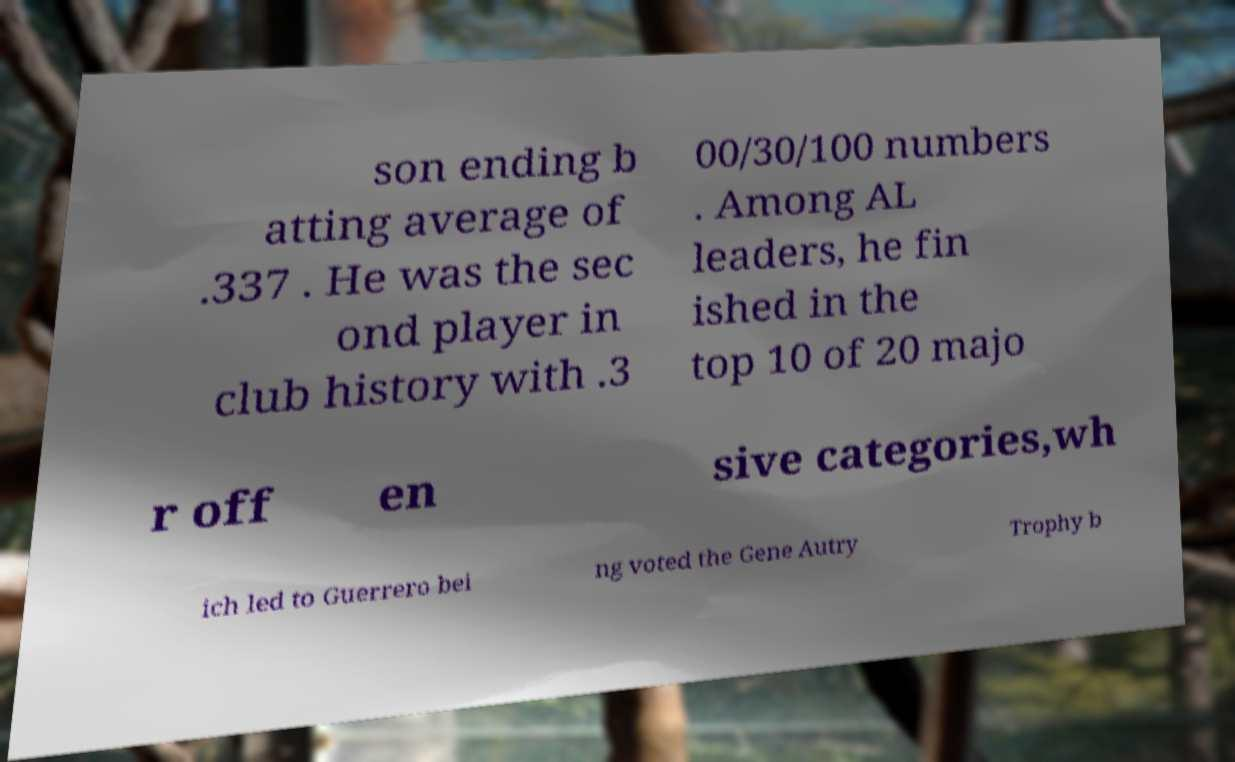Could you extract and type out the text from this image? son ending b atting average of .337 . He was the sec ond player in club history with .3 00/30/100 numbers . Among AL leaders, he fin ished in the top 10 of 20 majo r off en sive categories,wh ich led to Guerrero bei ng voted the Gene Autry Trophy b 